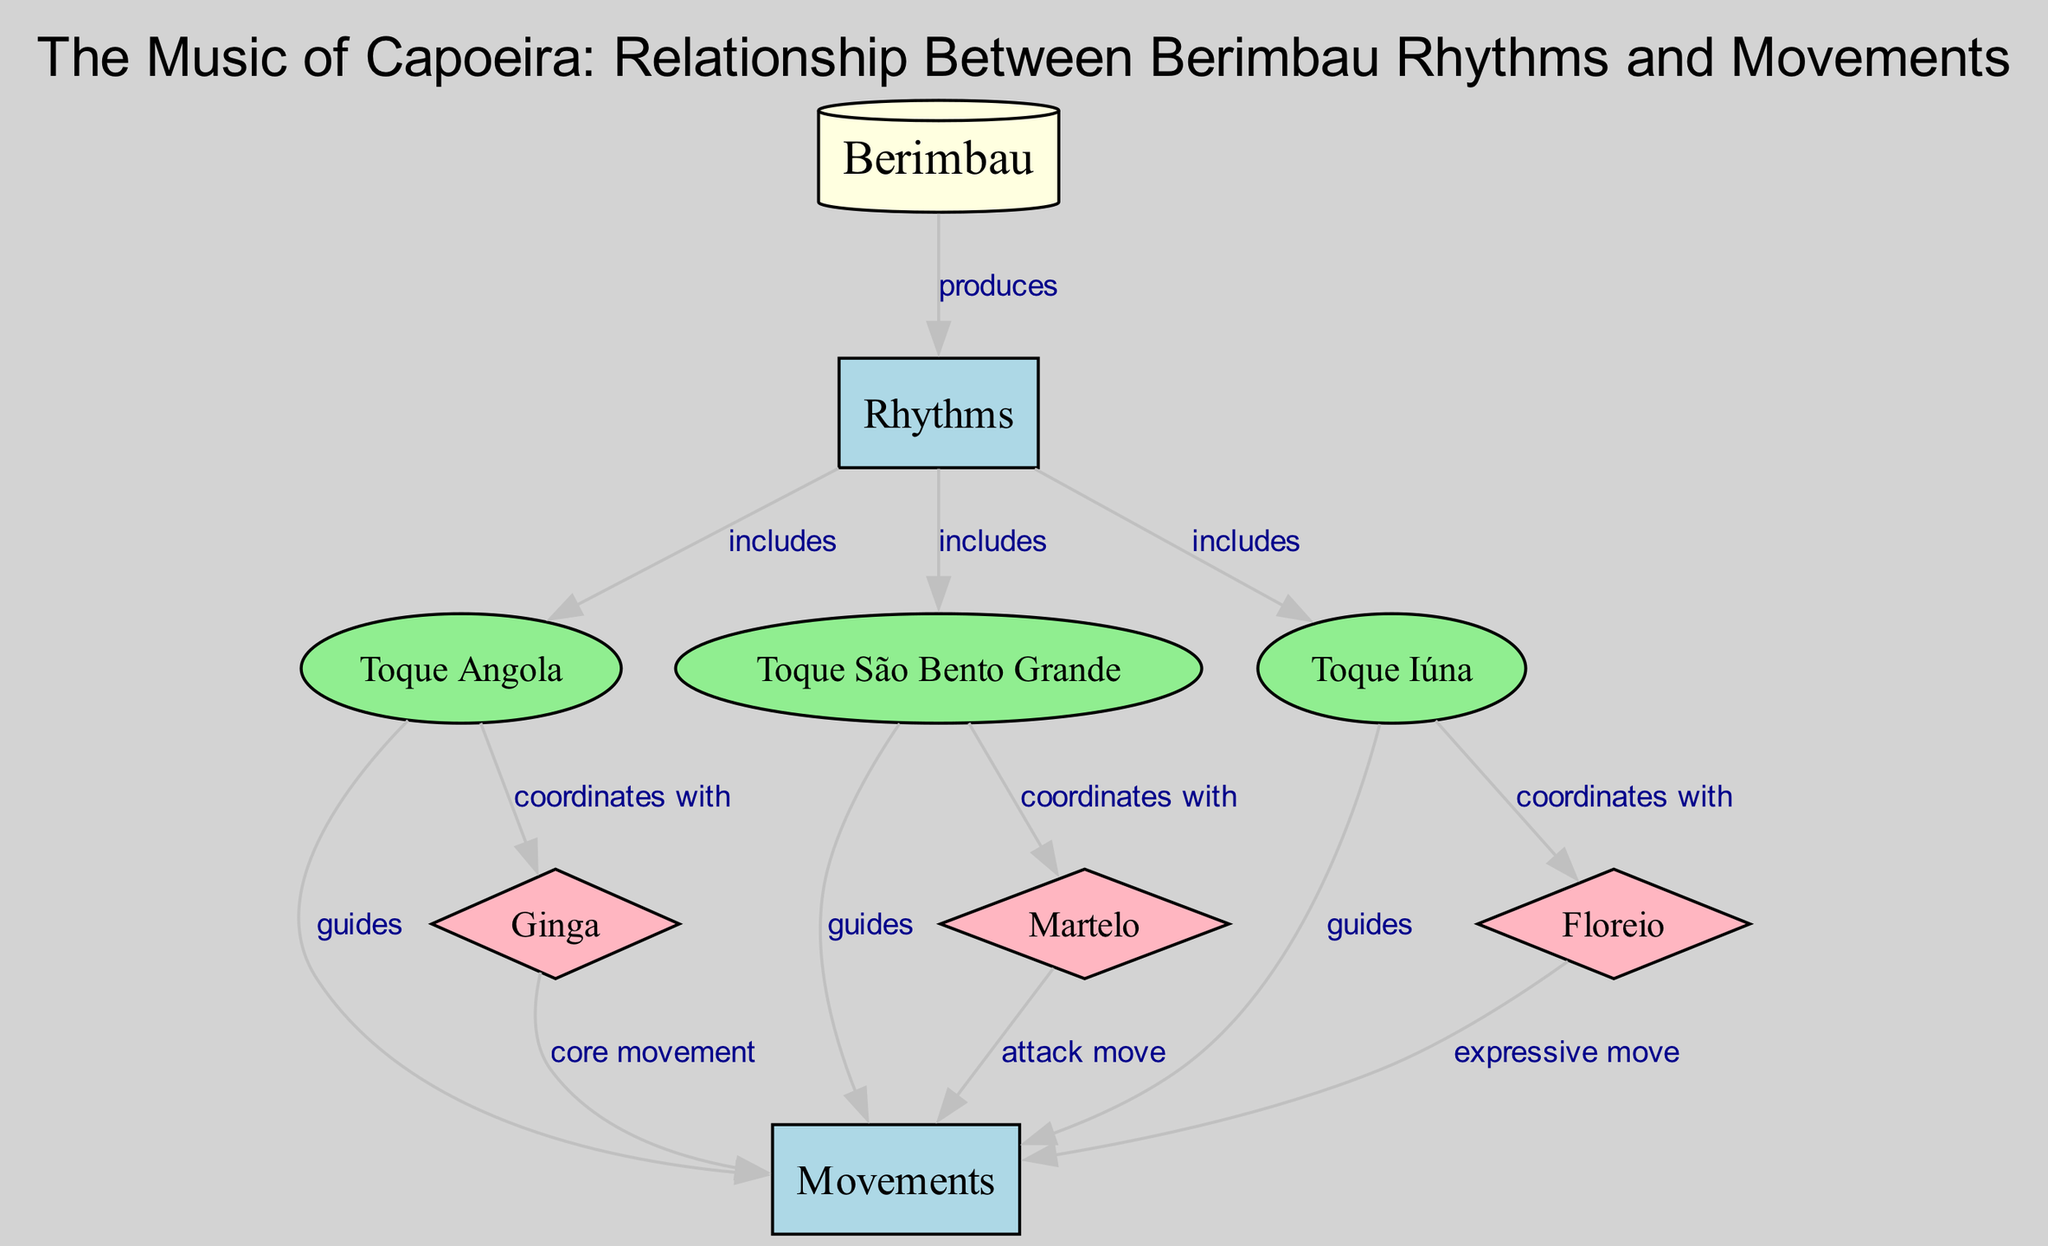What is the primary instrument featured in this diagram? The diagram clearly identifies the Berimbau as the primary instrument at the top, labeled as "Berimbau".
Answer: Berimbau How many rhythms are produced by the Berimbau? The diagram shows that the Berimbau produces three rhythms, which include Toque Angola, Toque São Bento Grande, and Toque Iúna.
Answer: Three Which rhythm is associated with the core movement of capoeira? The diagram connects "Ginga" as the core movement of capoeira, explicitly stating its relationship with rhythm.
Answer: Ginga What type of movement is illustrated by the Toque São Bento Grande? The diagram indicates that the Toque São Bento Grande guides an "attack move", represented by the connected node "Martelo".
Answer: Attack move How do Toque Iúna and Floreio relate to movements? The diagram shows that both Toque Iúna and Floreio guide movements in capoeira, directly indicating their relationship with the "Movements" node.
Answer: Guide What is the relationship between Toque Angola and Ginga? The diagram states that Toque Angola coordinates with Ginga, indicating a collaborative movement pattern in capoeira.
Answer: Coordinates with How many total edges connect the rhythms to movements? The diagram displays a total of six edges that indicate the connections between various rhythms and movements in capoeira.
Answer: Six Which rhythm includes the expressive move? The diagram demonstrates that Floreio is the rhythm associated with the expressive move, clearly linking it to the corresponding node.
Answer: Floreio Which rhythm includes the attack move? The diagram explicitly states that the Toque São Bento Grande guides the attack move, identifying its relationship with the "Martelo".
Answer: Toque São Bento Grande 